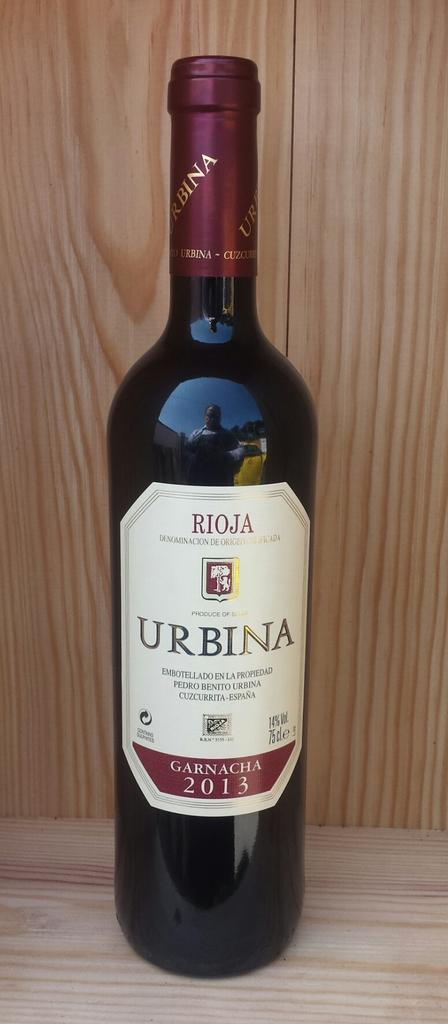<image>
Summarize the visual content of the image. A full unopened bottle of Rioja Urbina Garnaca 2013 wine with 14% alcohol volume. 